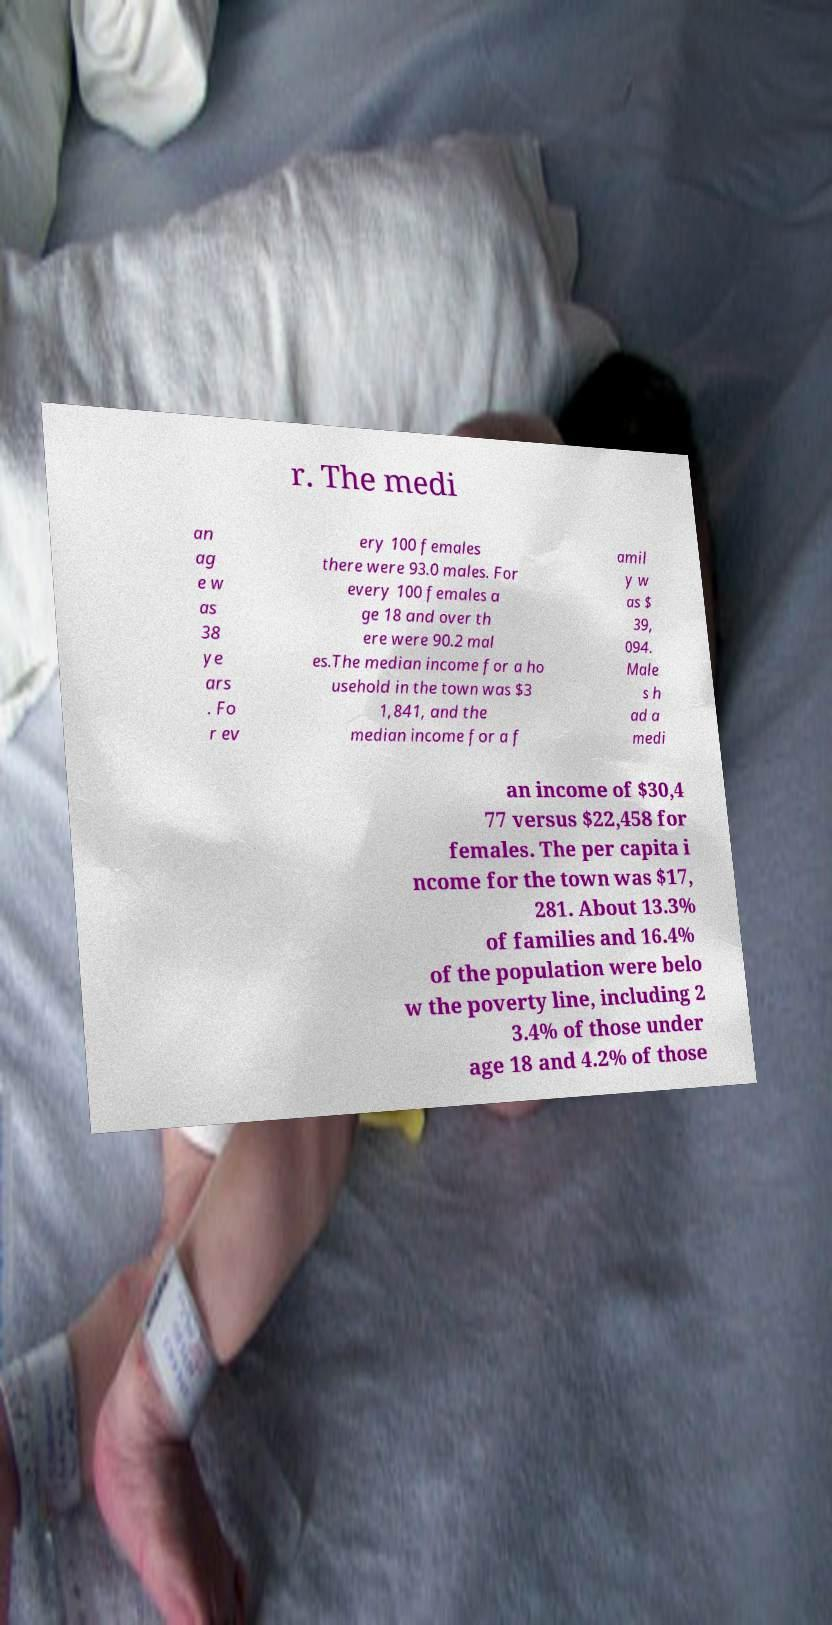I need the written content from this picture converted into text. Can you do that? r. The medi an ag e w as 38 ye ars . Fo r ev ery 100 females there were 93.0 males. For every 100 females a ge 18 and over th ere were 90.2 mal es.The median income for a ho usehold in the town was $3 1,841, and the median income for a f amil y w as $ 39, 094. Male s h ad a medi an income of $30,4 77 versus $22,458 for females. The per capita i ncome for the town was $17, 281. About 13.3% of families and 16.4% of the population were belo w the poverty line, including 2 3.4% of those under age 18 and 4.2% of those 